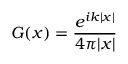Convert formula to latex. <formula><loc_0><loc_0><loc_500><loc_500>G ( x ) = { \frac { e ^ { i k | x | } } { 4 \pi | x | } }</formula> 